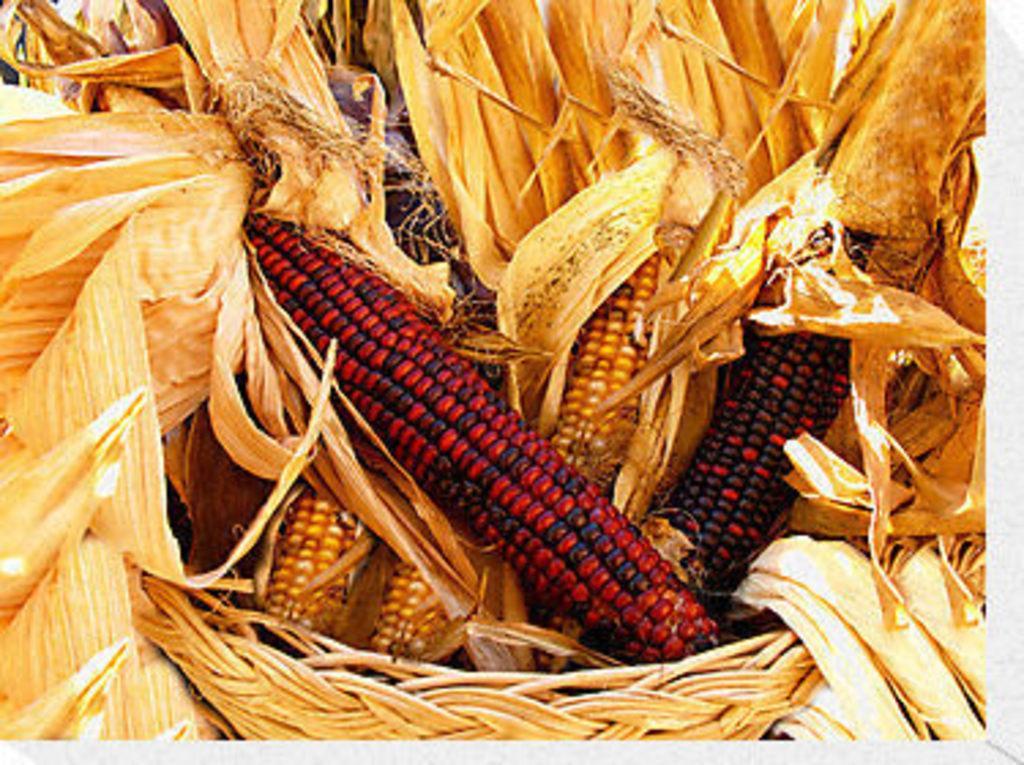In one or two sentences, can you explain what this image depicts? In this picture we can see corn. 